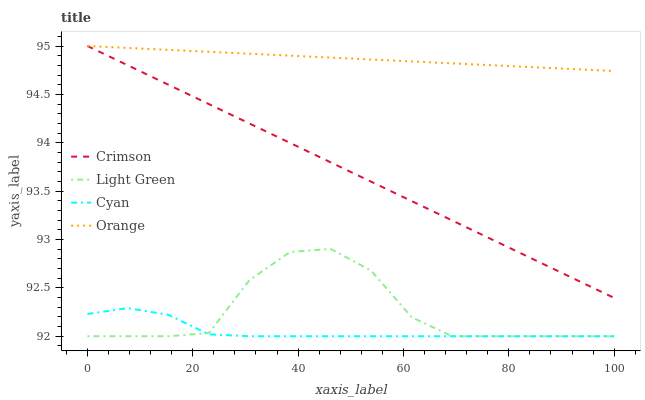Does Orange have the minimum area under the curve?
Answer yes or no. No. Does Cyan have the maximum area under the curve?
Answer yes or no. No. Is Cyan the smoothest?
Answer yes or no. No. Is Cyan the roughest?
Answer yes or no. No. Does Orange have the lowest value?
Answer yes or no. No. Does Cyan have the highest value?
Answer yes or no. No. Is Cyan less than Crimson?
Answer yes or no. Yes. Is Orange greater than Light Green?
Answer yes or no. Yes. Does Cyan intersect Crimson?
Answer yes or no. No. 